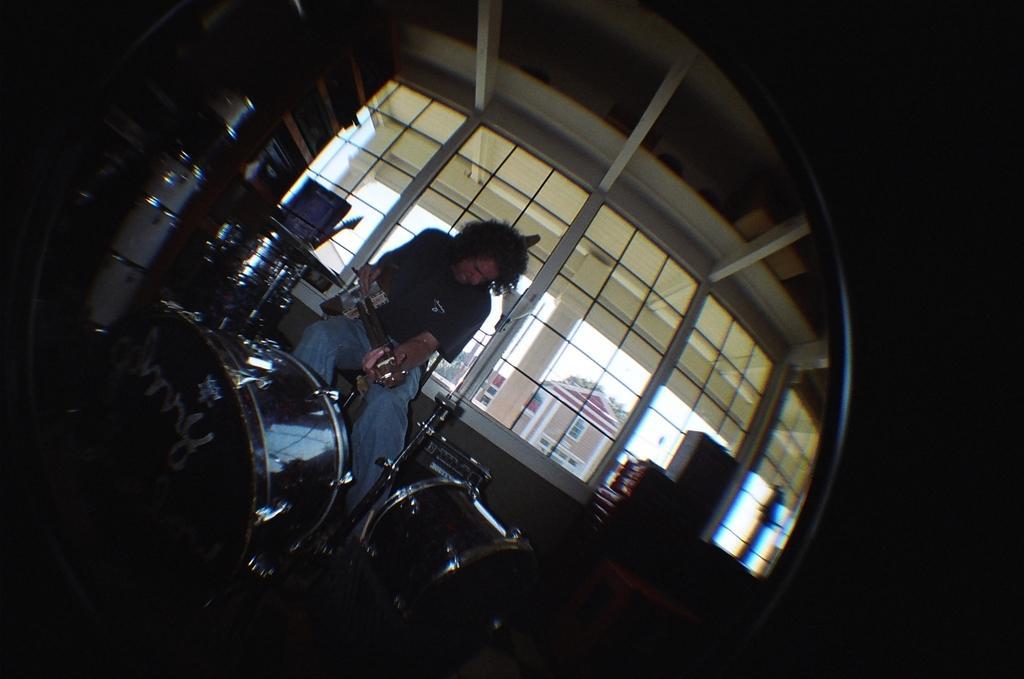Can you describe this image briefly? In this image I can see the person playing the musical instrument. In front I can see few musical instruments. In the background I can see few windows and I can also see the house, few trees in green color and the sky is in white color. 